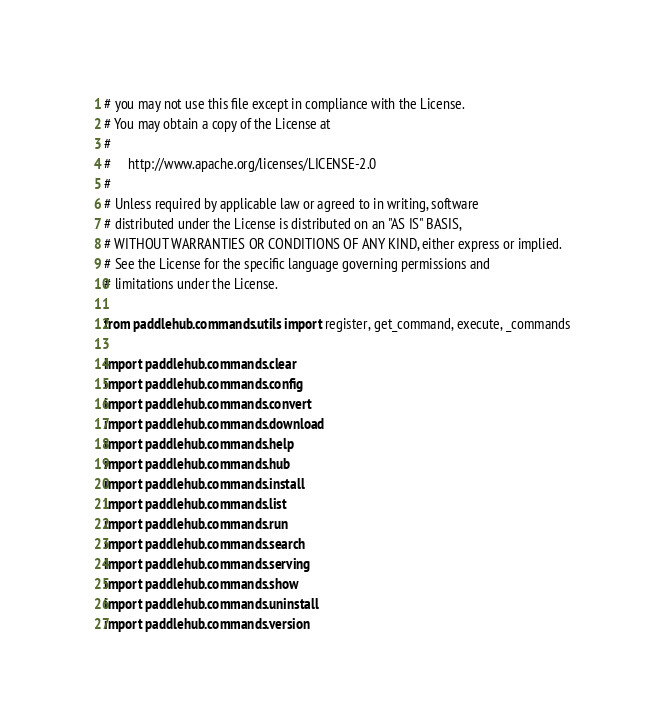<code> <loc_0><loc_0><loc_500><loc_500><_Python_># you may not use this file except in compliance with the License.
# You may obtain a copy of the License at
#
#     http://www.apache.org/licenses/LICENSE-2.0
#
# Unless required by applicable law or agreed to in writing, software
# distributed under the License is distributed on an "AS IS" BASIS,
# WITHOUT WARRANTIES OR CONDITIONS OF ANY KIND, either express or implied.
# See the License for the specific language governing permissions and
# limitations under the License.

from paddlehub.commands.utils import register, get_command, execute, _commands

import paddlehub.commands.clear
import paddlehub.commands.config
import paddlehub.commands.convert
import paddlehub.commands.download
import paddlehub.commands.help
import paddlehub.commands.hub
import paddlehub.commands.install
import paddlehub.commands.list
import paddlehub.commands.run
import paddlehub.commands.search
import paddlehub.commands.serving
import paddlehub.commands.show
import paddlehub.commands.uninstall
import paddlehub.commands.version
</code> 